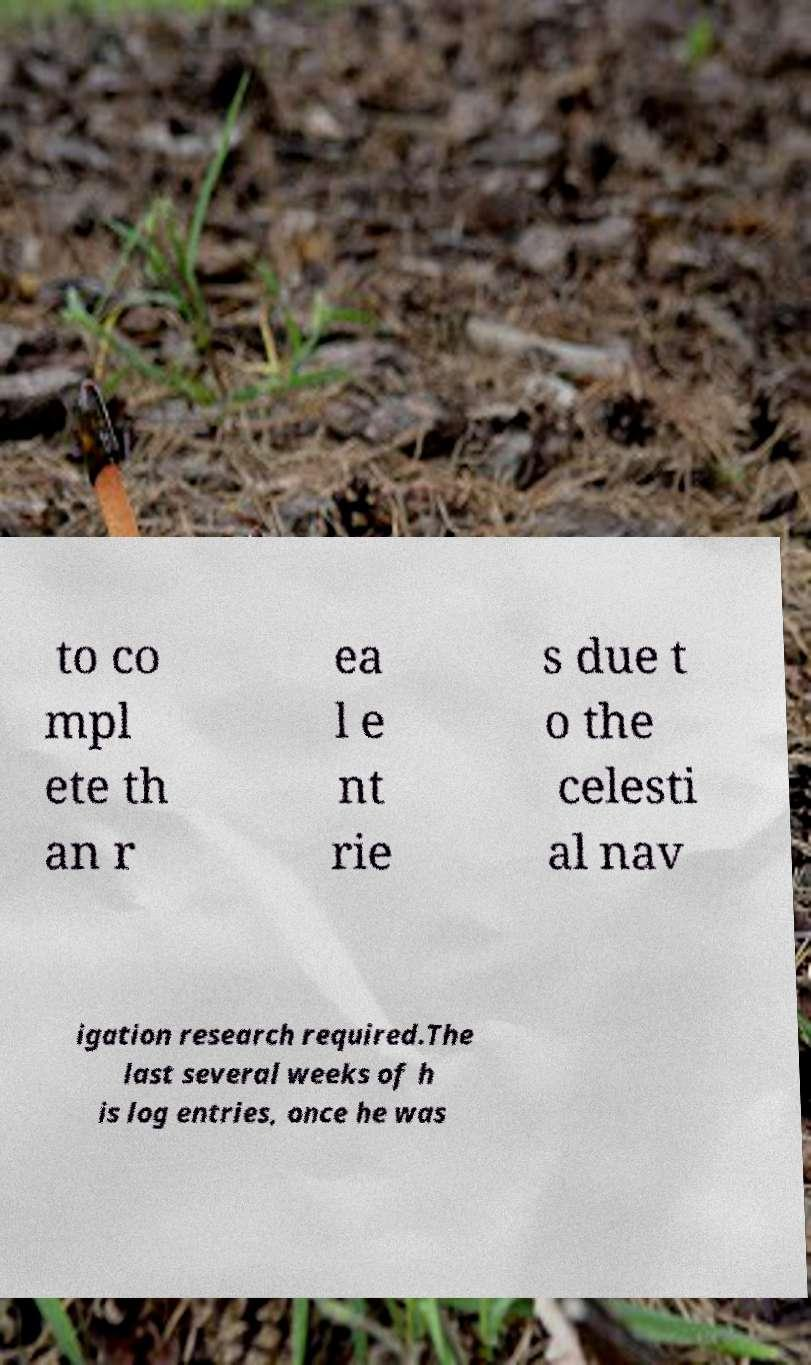I need the written content from this picture converted into text. Can you do that? to co mpl ete th an r ea l e nt rie s due t o the celesti al nav igation research required.The last several weeks of h is log entries, once he was 